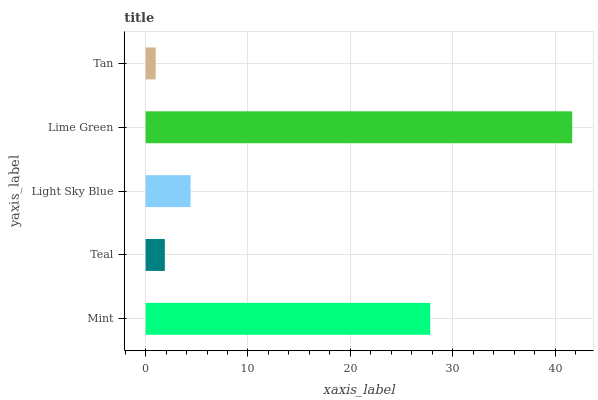Is Tan the minimum?
Answer yes or no. Yes. Is Lime Green the maximum?
Answer yes or no. Yes. Is Teal the minimum?
Answer yes or no. No. Is Teal the maximum?
Answer yes or no. No. Is Mint greater than Teal?
Answer yes or no. Yes. Is Teal less than Mint?
Answer yes or no. Yes. Is Teal greater than Mint?
Answer yes or no. No. Is Mint less than Teal?
Answer yes or no. No. Is Light Sky Blue the high median?
Answer yes or no. Yes. Is Light Sky Blue the low median?
Answer yes or no. Yes. Is Lime Green the high median?
Answer yes or no. No. Is Lime Green the low median?
Answer yes or no. No. 